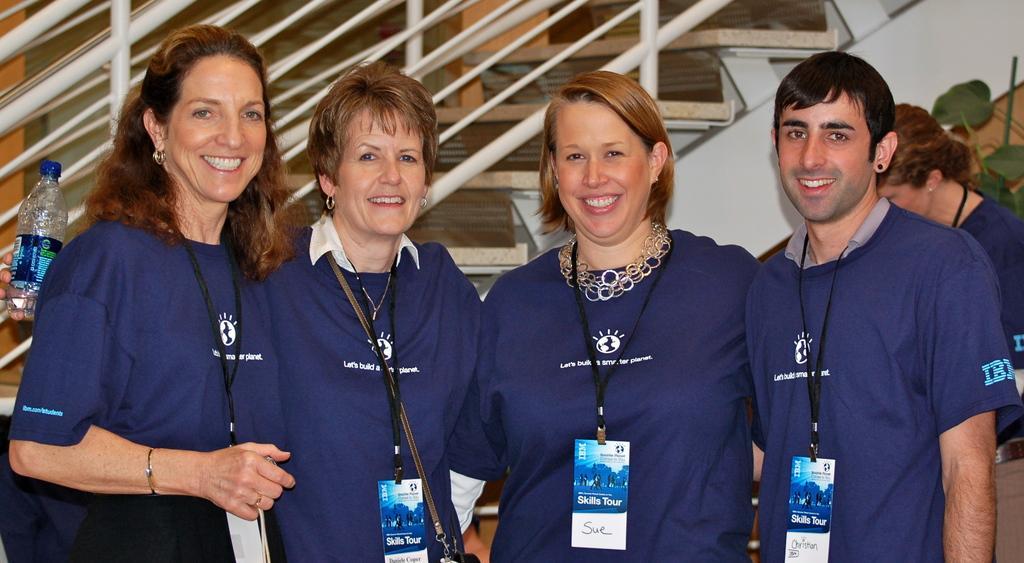Can you describe this image briefly? In this image there are people standing. They are wearing blue tops and badges. Left side a person's hand is visible. He is holding a bottle. Background there is a staircase. Right side there is a plant. 